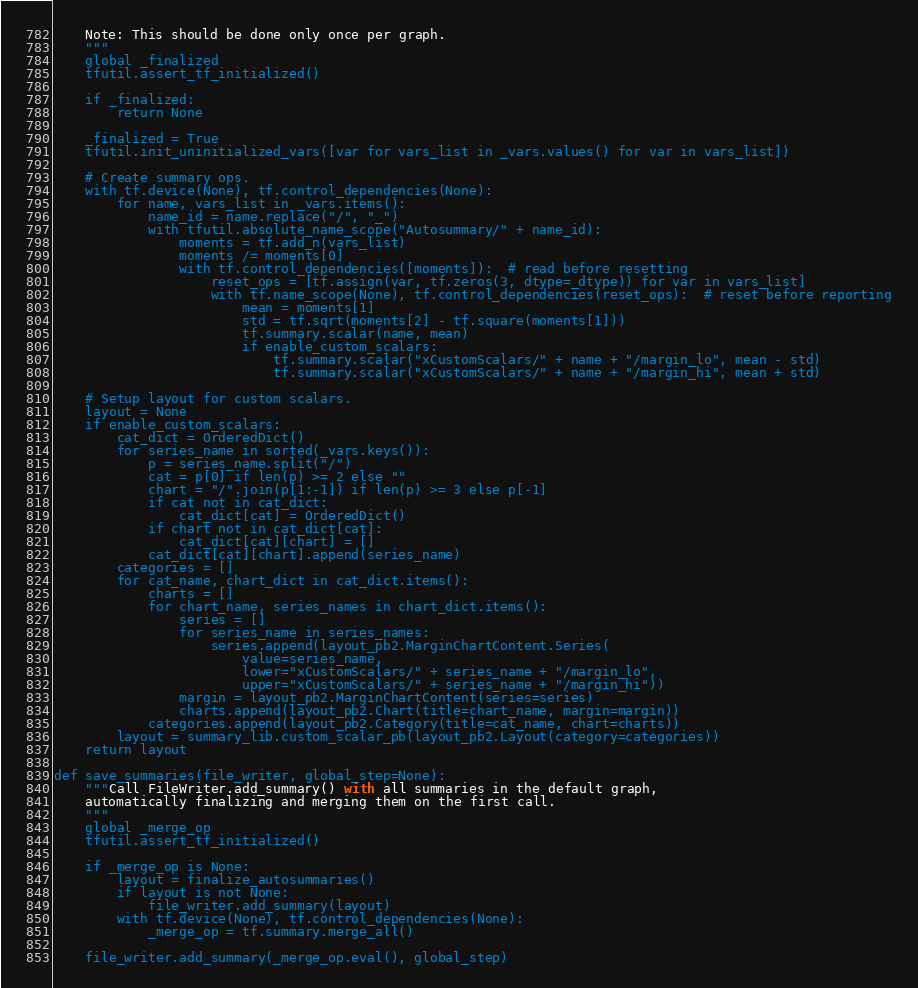Convert code to text. <code><loc_0><loc_0><loc_500><loc_500><_Python_>    Note: This should be done only once per graph.
    """
    global _finalized
    tfutil.assert_tf_initialized()

    if _finalized:
        return None

    _finalized = True
    tfutil.init_uninitialized_vars([var for vars_list in _vars.values() for var in vars_list])

    # Create summary ops.
    with tf.device(None), tf.control_dependencies(None):
        for name, vars_list in _vars.items():
            name_id = name.replace("/", "_")
            with tfutil.absolute_name_scope("Autosummary/" + name_id):
                moments = tf.add_n(vars_list)
                moments /= moments[0]
                with tf.control_dependencies([moments]):  # read before resetting
                    reset_ops = [tf.assign(var, tf.zeros(3, dtype=_dtype)) for var in vars_list]
                    with tf.name_scope(None), tf.control_dependencies(reset_ops):  # reset before reporting
                        mean = moments[1]
                        std = tf.sqrt(moments[2] - tf.square(moments[1]))
                        tf.summary.scalar(name, mean)
                        if enable_custom_scalars:
                            tf.summary.scalar("xCustomScalars/" + name + "/margin_lo", mean - std)
                            tf.summary.scalar("xCustomScalars/" + name + "/margin_hi", mean + std)

    # Setup layout for custom scalars.
    layout = None
    if enable_custom_scalars:
        cat_dict = OrderedDict()
        for series_name in sorted(_vars.keys()):
            p = series_name.split("/")
            cat = p[0] if len(p) >= 2 else ""
            chart = "/".join(p[1:-1]) if len(p) >= 3 else p[-1]
            if cat not in cat_dict:
                cat_dict[cat] = OrderedDict()
            if chart not in cat_dict[cat]:
                cat_dict[cat][chart] = []
            cat_dict[cat][chart].append(series_name)
        categories = []
        for cat_name, chart_dict in cat_dict.items():
            charts = []
            for chart_name, series_names in chart_dict.items():
                series = []
                for series_name in series_names:
                    series.append(layout_pb2.MarginChartContent.Series(
                        value=series_name,
                        lower="xCustomScalars/" + series_name + "/margin_lo",
                        upper="xCustomScalars/" + series_name + "/margin_hi"))
                margin = layout_pb2.MarginChartContent(series=series)
                charts.append(layout_pb2.Chart(title=chart_name, margin=margin))
            categories.append(layout_pb2.Category(title=cat_name, chart=charts))
        layout = summary_lib.custom_scalar_pb(layout_pb2.Layout(category=categories))
    return layout

def save_summaries(file_writer, global_step=None):
    """Call FileWriter.add_summary() with all summaries in the default graph,
    automatically finalizing and merging them on the first call.
    """
    global _merge_op
    tfutil.assert_tf_initialized()

    if _merge_op is None:
        layout = finalize_autosummaries()
        if layout is not None:
            file_writer.add_summary(layout)
        with tf.device(None), tf.control_dependencies(None):
            _merge_op = tf.summary.merge_all()

    file_writer.add_summary(_merge_op.eval(), global_step)
</code> 